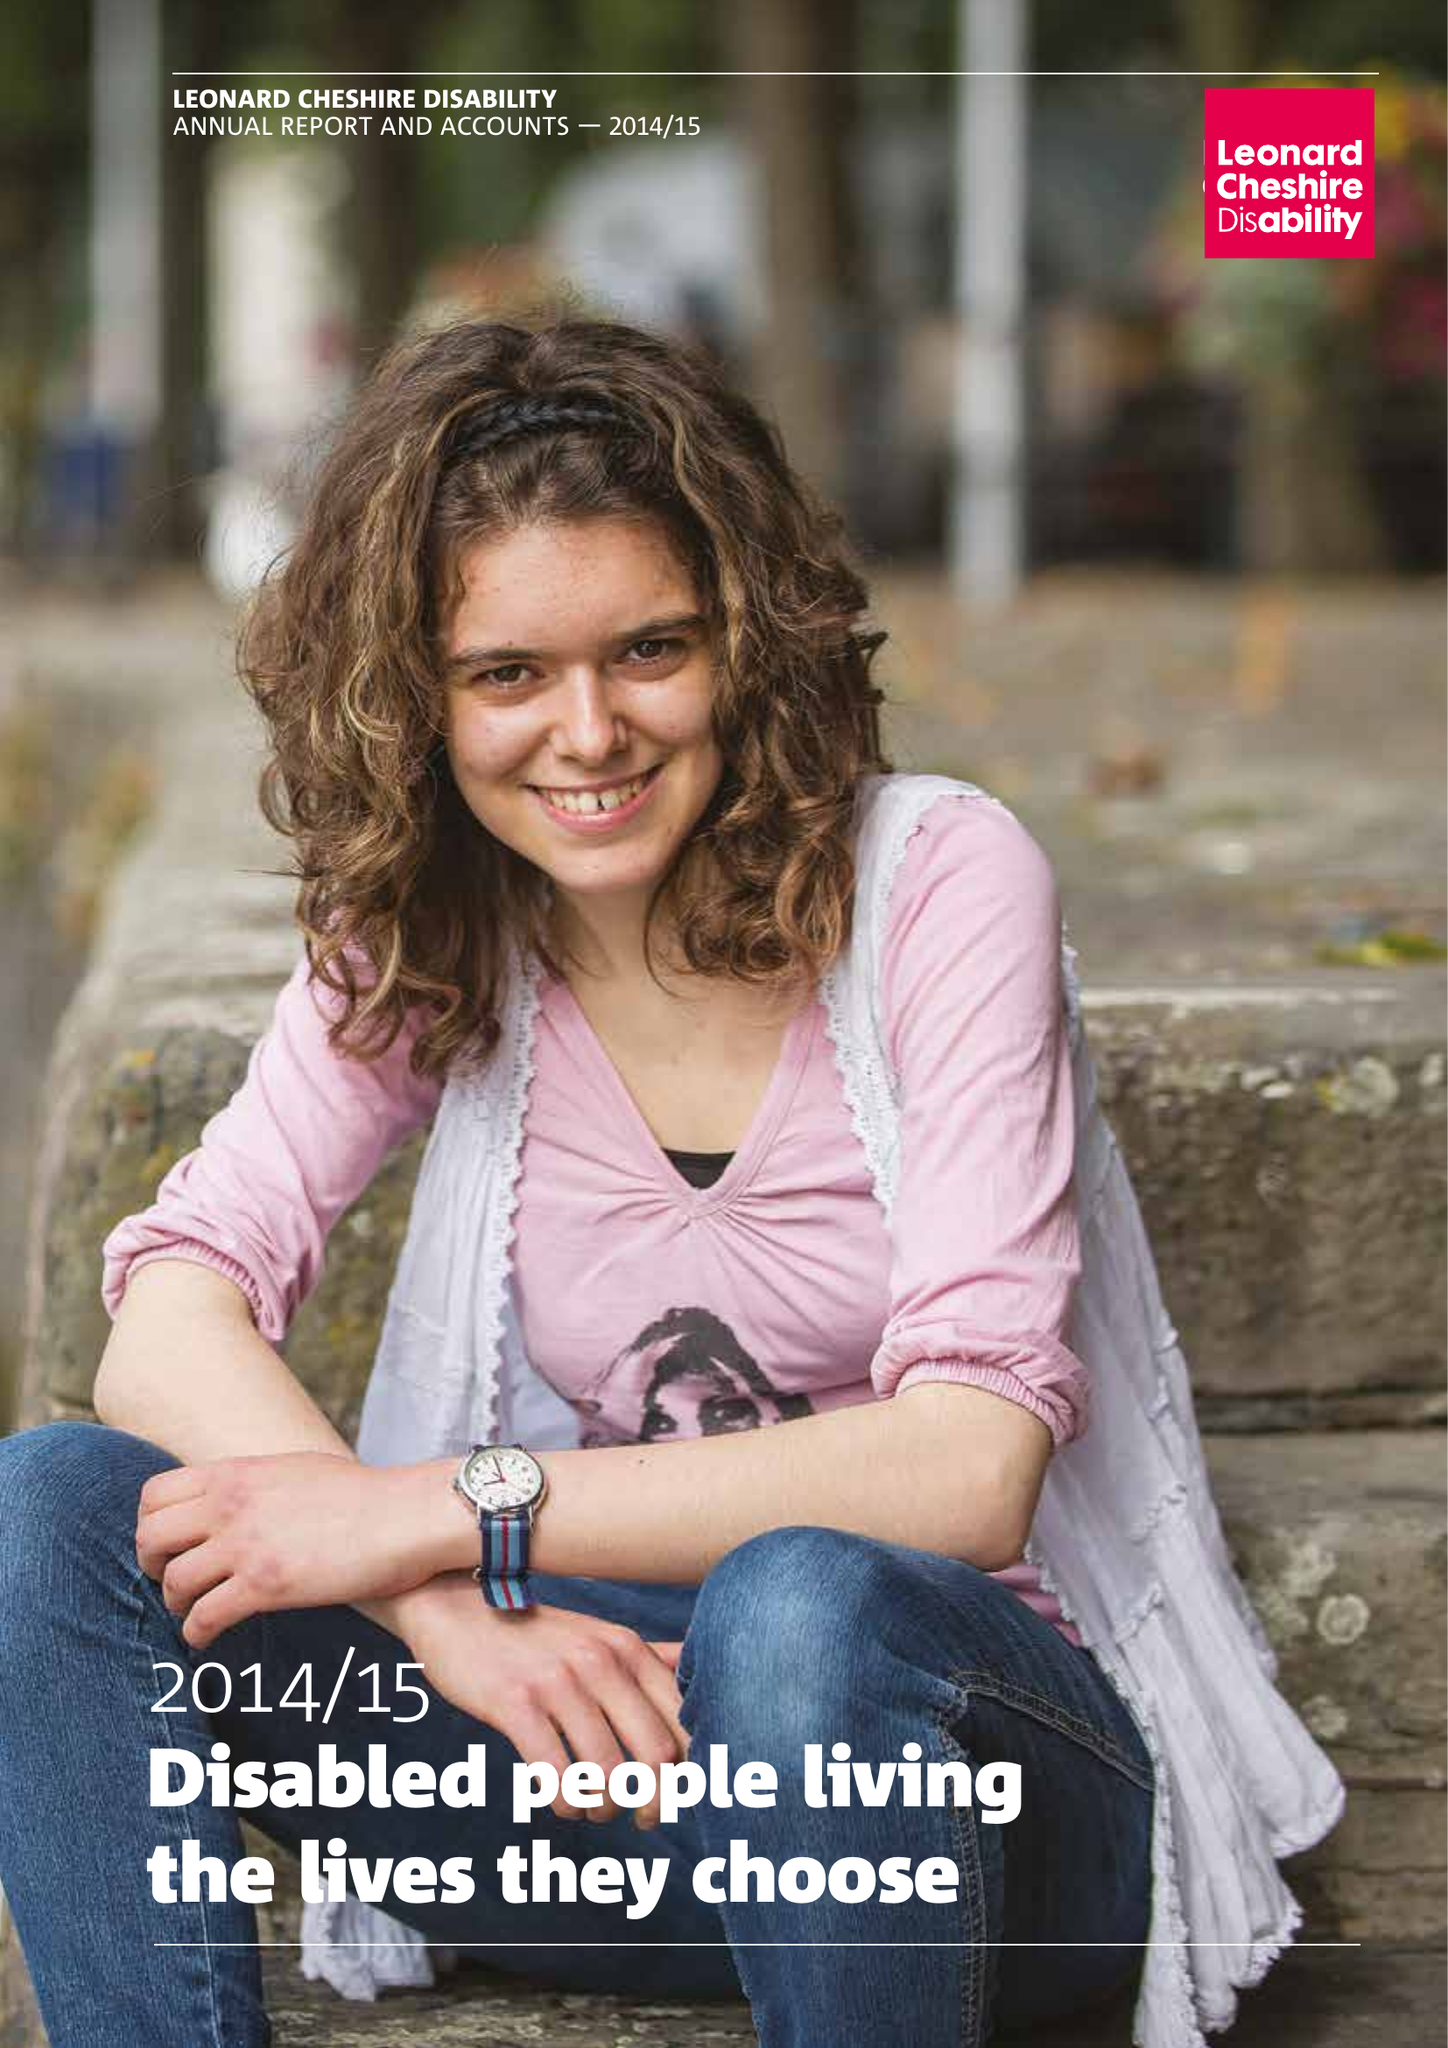What is the value for the report_date?
Answer the question using a single word or phrase. 2015-03-31 